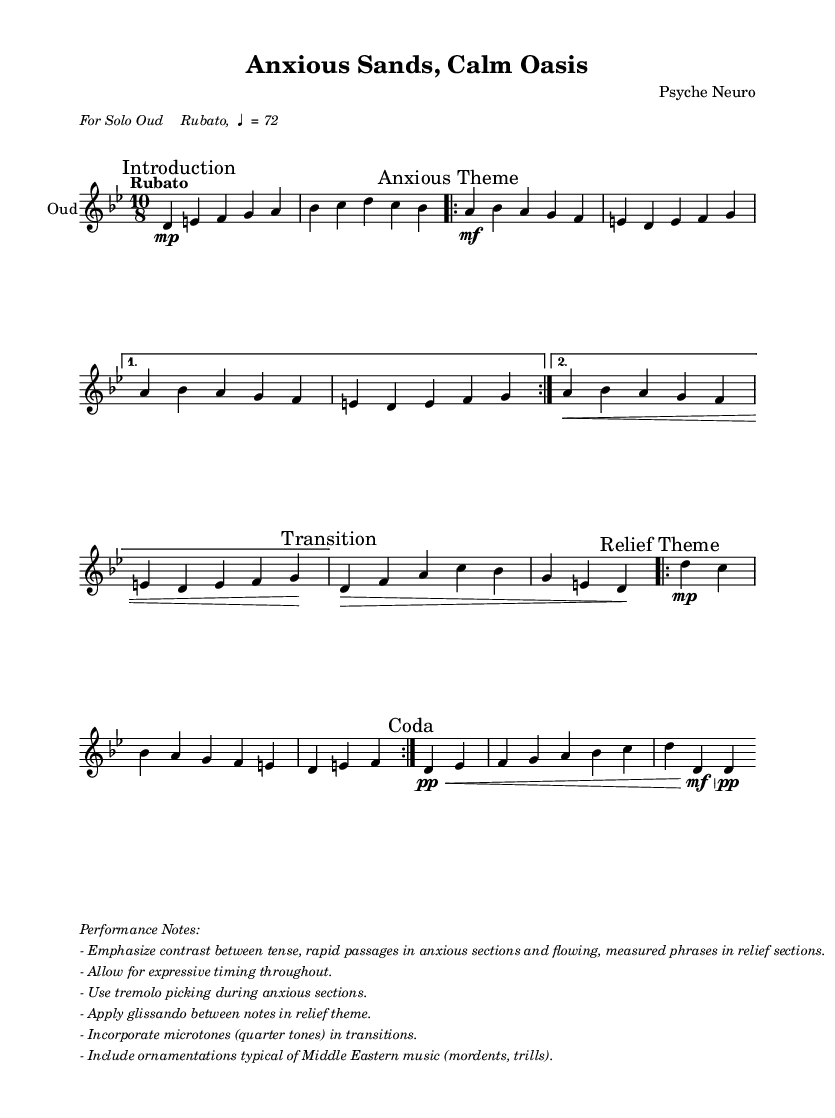What is the time signature of this music? The time signature is indicated at the beginning of the piece, shown as 10/8. This means there are ten eighth notes in each measure.
Answer: 10/8 What is the key signature of this music? The key signature is specified as D Phrygian, which typically uses the notes of D minor scale but emphasizes the 2nd degree. In this case, it includes the notes D, E, F, G, A, B, and C.
Answer: D Phrygian What is the tempo marking for the composition? The tempo marking is located in the introductory section of the sheet music, indicating "Rubato, ♩ = 72", which suggests a flexible tempo at 72 beats per minute.
Answer: Rubato, ♩ = 72 How many times is the Anxious Theme repeated? It states that the Anxious Theme is to be repeated twice, as indicated by the "repeat volta 2" instruction.
Answer: Twice What performance technique is suggested for the anxious sections? The music suggests using "tremolo picking" in the anxious sections, which allows for rapid note execution, creating a feeling of tension.
Answer: Tremolo picking What should be emphasized in the contrast between themes? The performance notes explicitly indicate to emphasize the contrast between the tense, rapid passages in the anxious sections and the flowing, measured phrases in the relief sections.
Answer: Contrast What is a suggested ornamentation technique for Middle Eastern music featured in this piece? The performance notes recommend incorporating "ornamentations typical of Middle Eastern music", including techniques like mordents and trills, which are common in this musical tradition.
Answer: Mordents, trills 